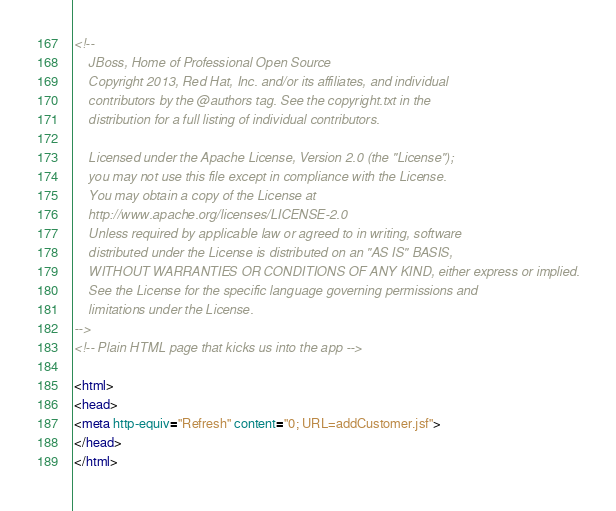<code> <loc_0><loc_0><loc_500><loc_500><_HTML_><!--
    JBoss, Home of Professional Open Source
    Copyright 2013, Red Hat, Inc. and/or its affiliates, and individual
    contributors by the @authors tag. See the copyright.txt in the
    distribution for a full listing of individual contributors.

    Licensed under the Apache License, Version 2.0 (the "License");
    you may not use this file except in compliance with the License.
    You may obtain a copy of the License at
    http://www.apache.org/licenses/LICENSE-2.0
    Unless required by applicable law or agreed to in writing, software
    distributed under the License is distributed on an "AS IS" BASIS,
    WITHOUT WARRANTIES OR CONDITIONS OF ANY KIND, either express or implied.
    See the License for the specific language governing permissions and
    limitations under the License.
-->
<!-- Plain HTML page that kicks us into the app -->

<html>
<head>
<meta http-equiv="Refresh" content="0; URL=addCustomer.jsf">
</head>
</html>
</code> 